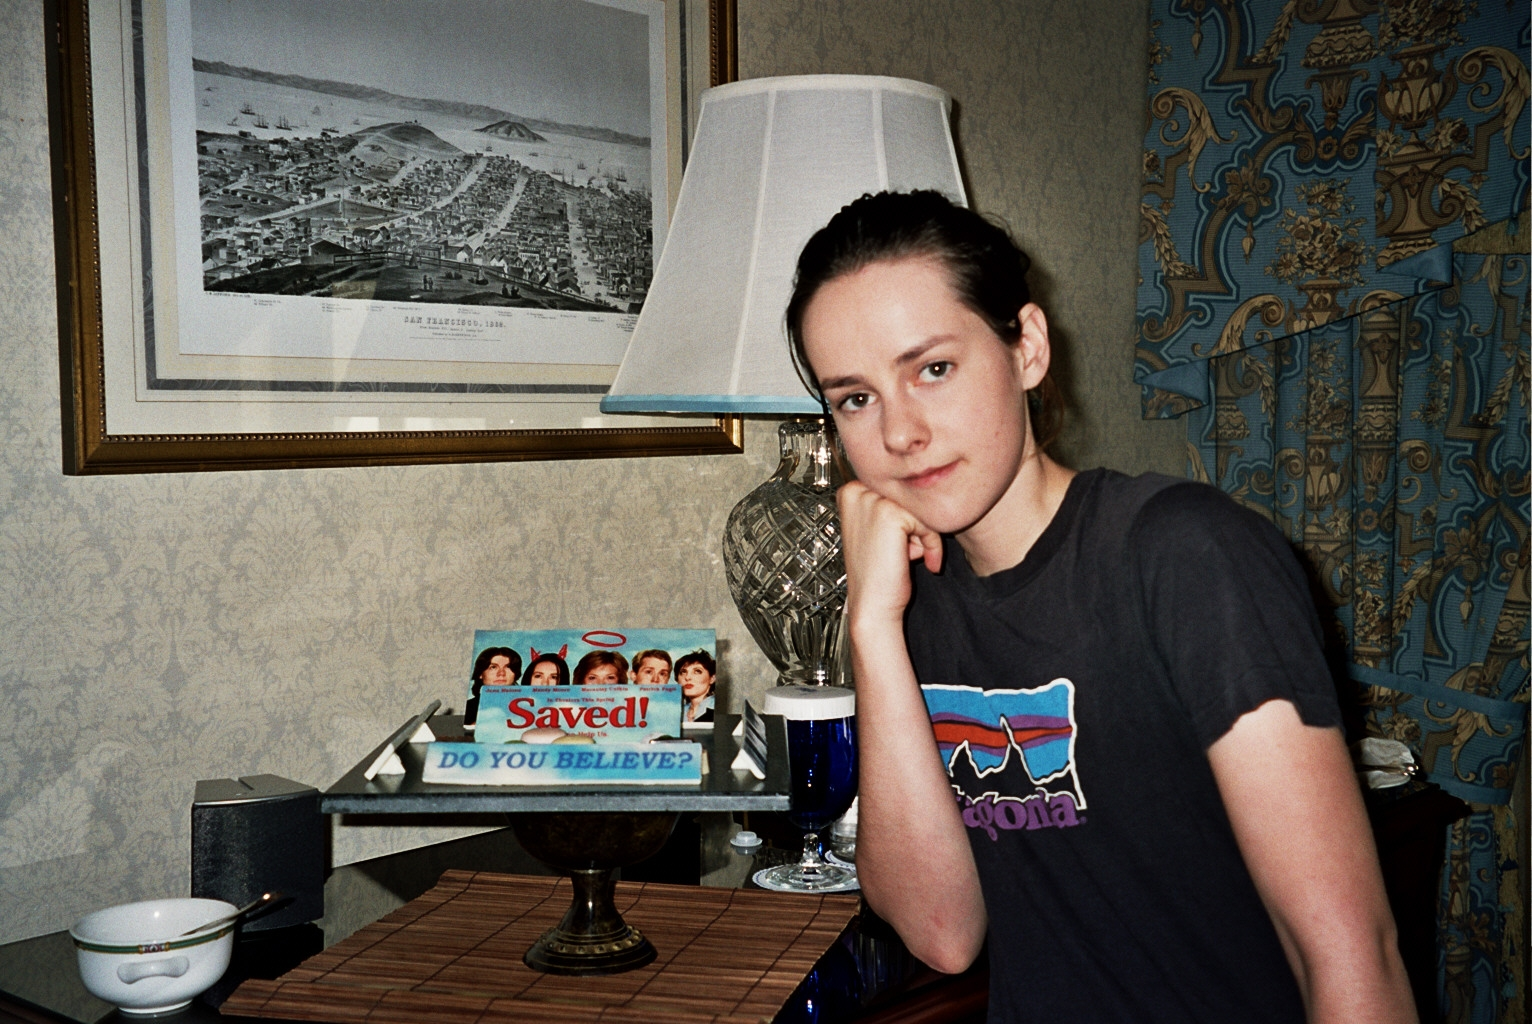If the objects on the table could talk, what story would they tell? If the objects on the table could talk, they might tell the story of a peaceful evening at home. The teacup, often filled with chamomile or green tea, recounts moments of tranquility. The DVD cover of 'Saved!' shares memories of laughter and contemplation about the movie’s themes. The table lamp adds its tale of shedding light on late-night reading sessions. Together, these objects weave a narrative of quiet introspection and personal solace. 